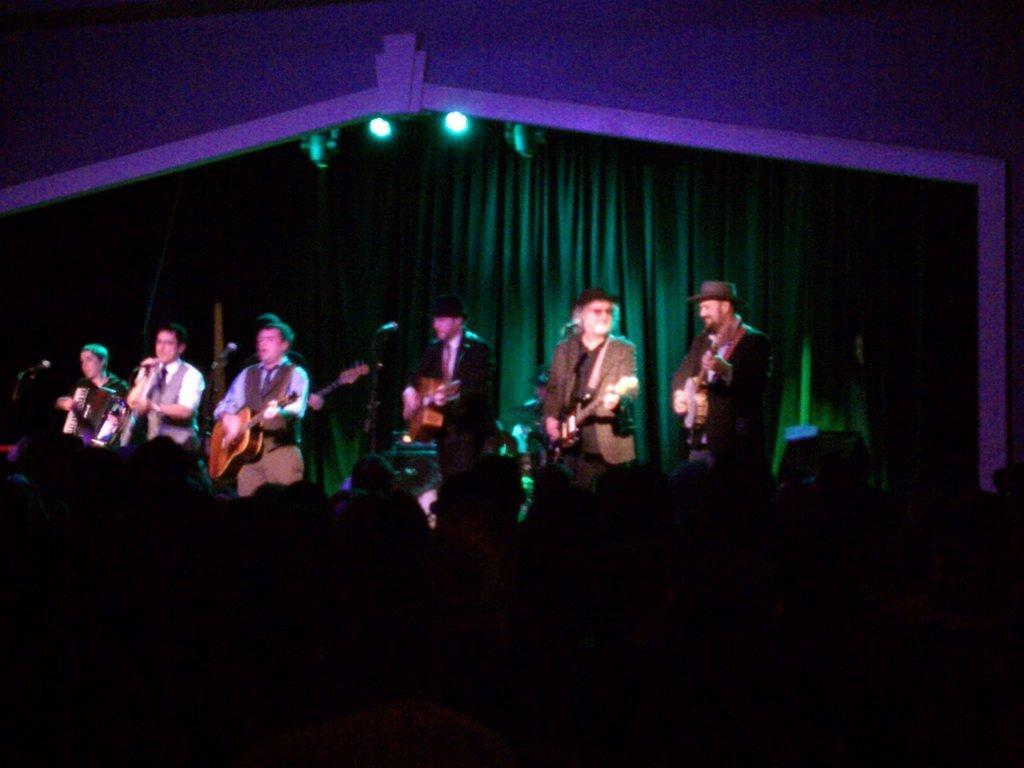In one or two sentences, can you explain what this image depicts? In this image there are so many people standing on stage and playing musical instruments behind them there is a curtain hanging and some lights on the roof. 